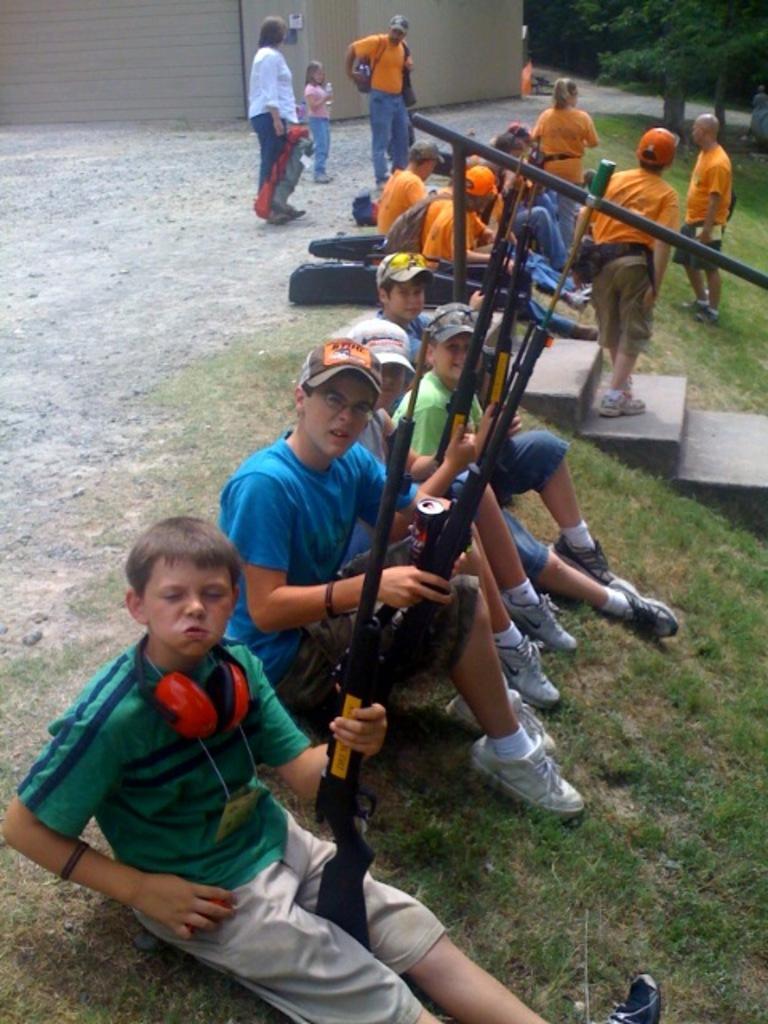How would you summarize this image in a sentence or two? In this picture there is a group of boys sitting on the grass holding the guns and giving a pose into the camera. Behind there is a group of girls and boys wearing orange color t-shirt sitting on the steps and discussing something. In the background there is a grey color wall and some trees. 